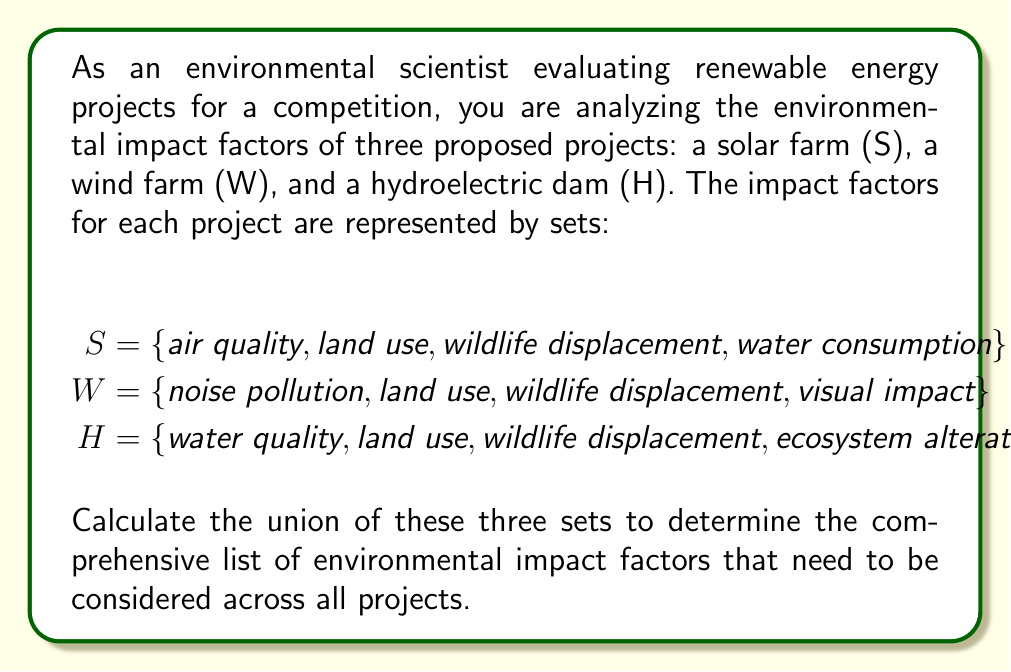Help me with this question. To solve this problem, we need to find the union of the three sets S, W, and H. The union of sets includes all unique elements from all sets, without repetition.

Let's follow these steps:

1. List all elements from set S:
   {air quality, land use, wildlife displacement, water consumption}

2. Add unique elements from set W:
   - "noise pollution" and "visual impact" are new, so we add them
   - "land use" and "wildlife displacement" are already included

3. Add unique elements from set H:
   - "water quality" and "ecosystem alteration" are new, so we add them
   - "land use" and "wildlife displacement" are already included

4. Combine all unique elements to form the union:

   $S \cup W \cup H = \{$ air quality, land use, wildlife displacement, water consumption, noise pollution, visual impact, water quality, ecosystem alteration $\}$

The resulting set contains 8 unique environmental impact factors that need to be considered across all projects.
Answer: $S \cup W \cup H = \{$ air quality, land use, wildlife displacement, water consumption, noise pollution, visual impact, water quality, ecosystem alteration $\}$ 